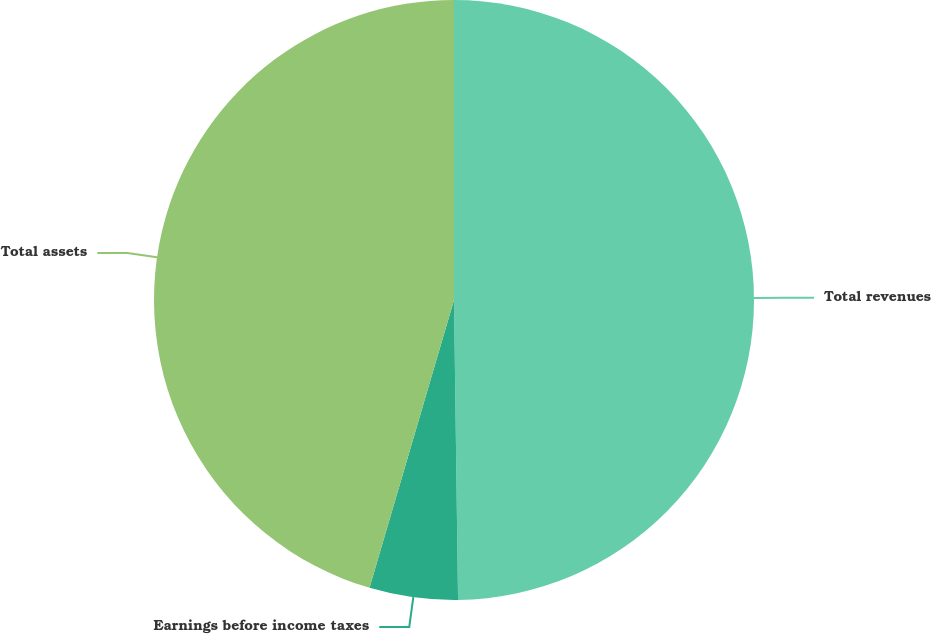<chart> <loc_0><loc_0><loc_500><loc_500><pie_chart><fcel>Total revenues<fcel>Earnings before income taxes<fcel>Total assets<nl><fcel>49.79%<fcel>4.76%<fcel>45.46%<nl></chart> 